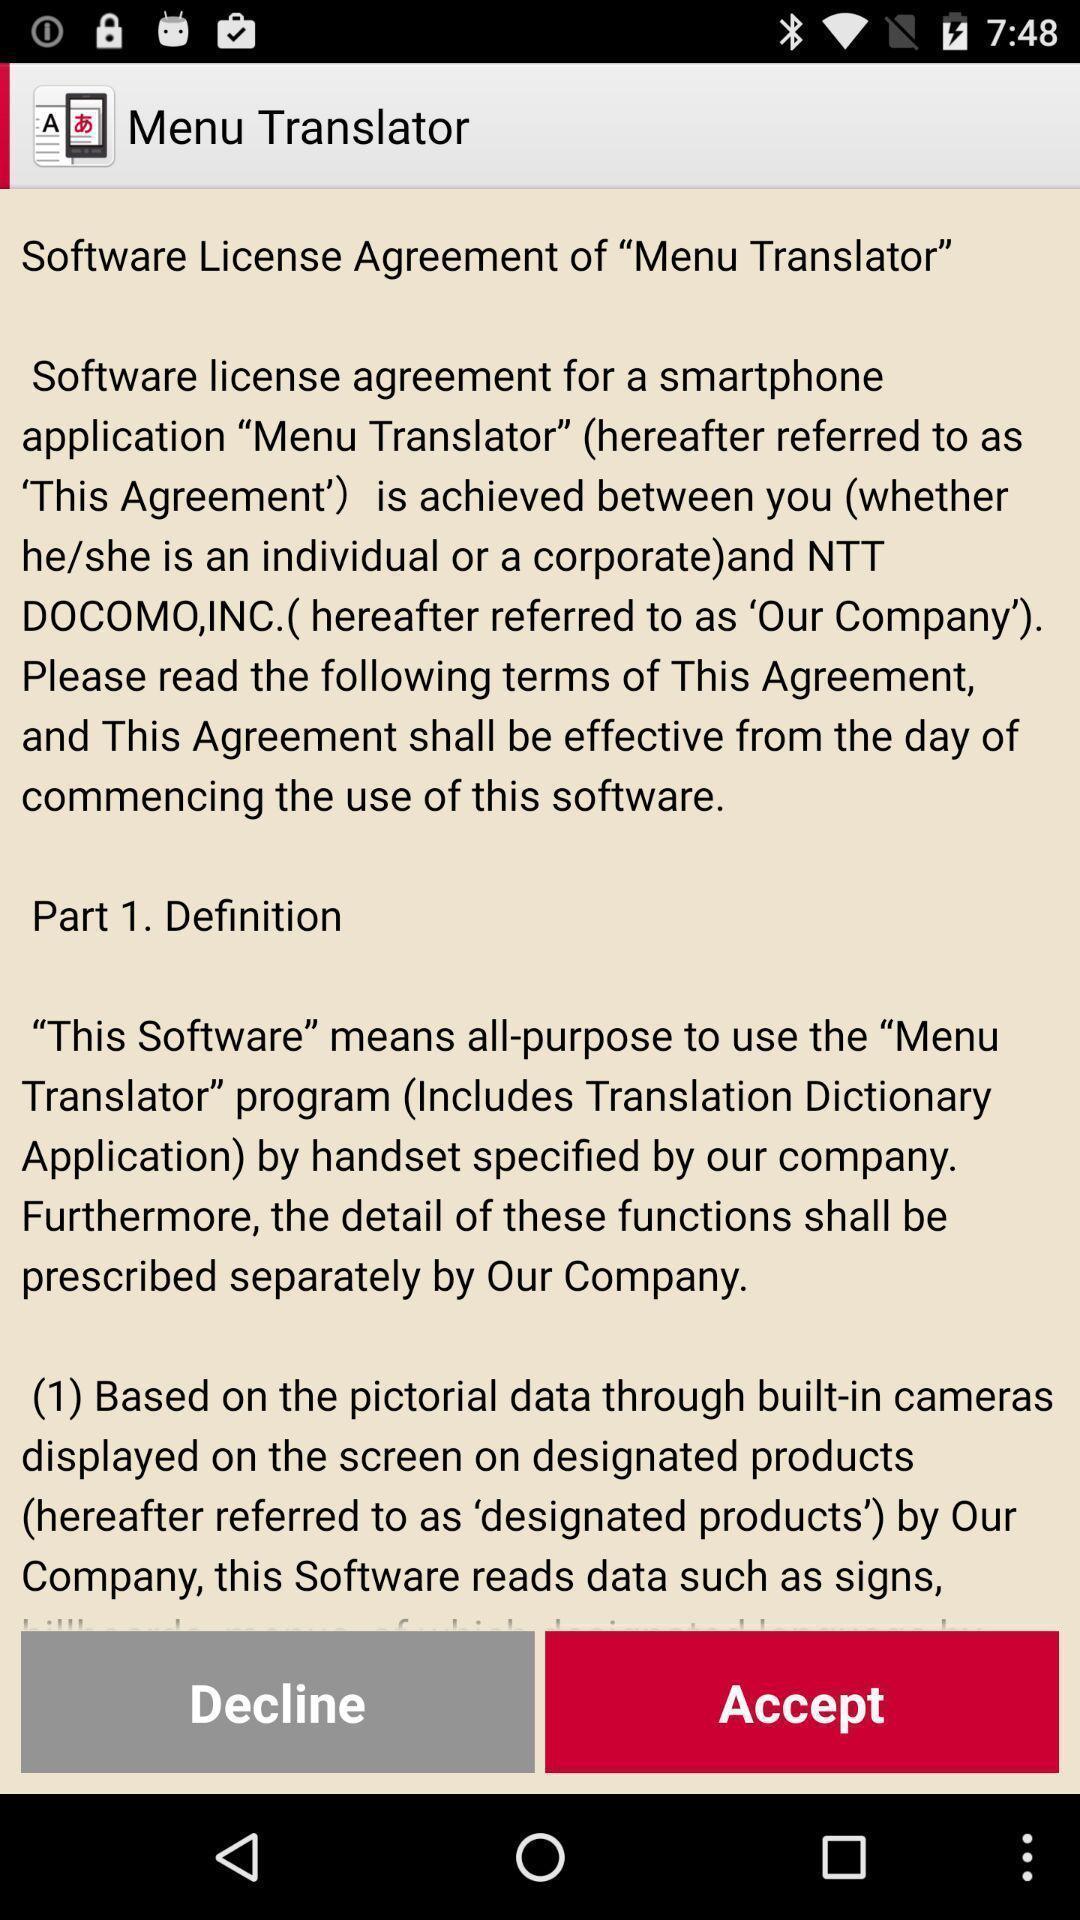Describe the key features of this screenshot. Screen displaying information about a language translation application. 